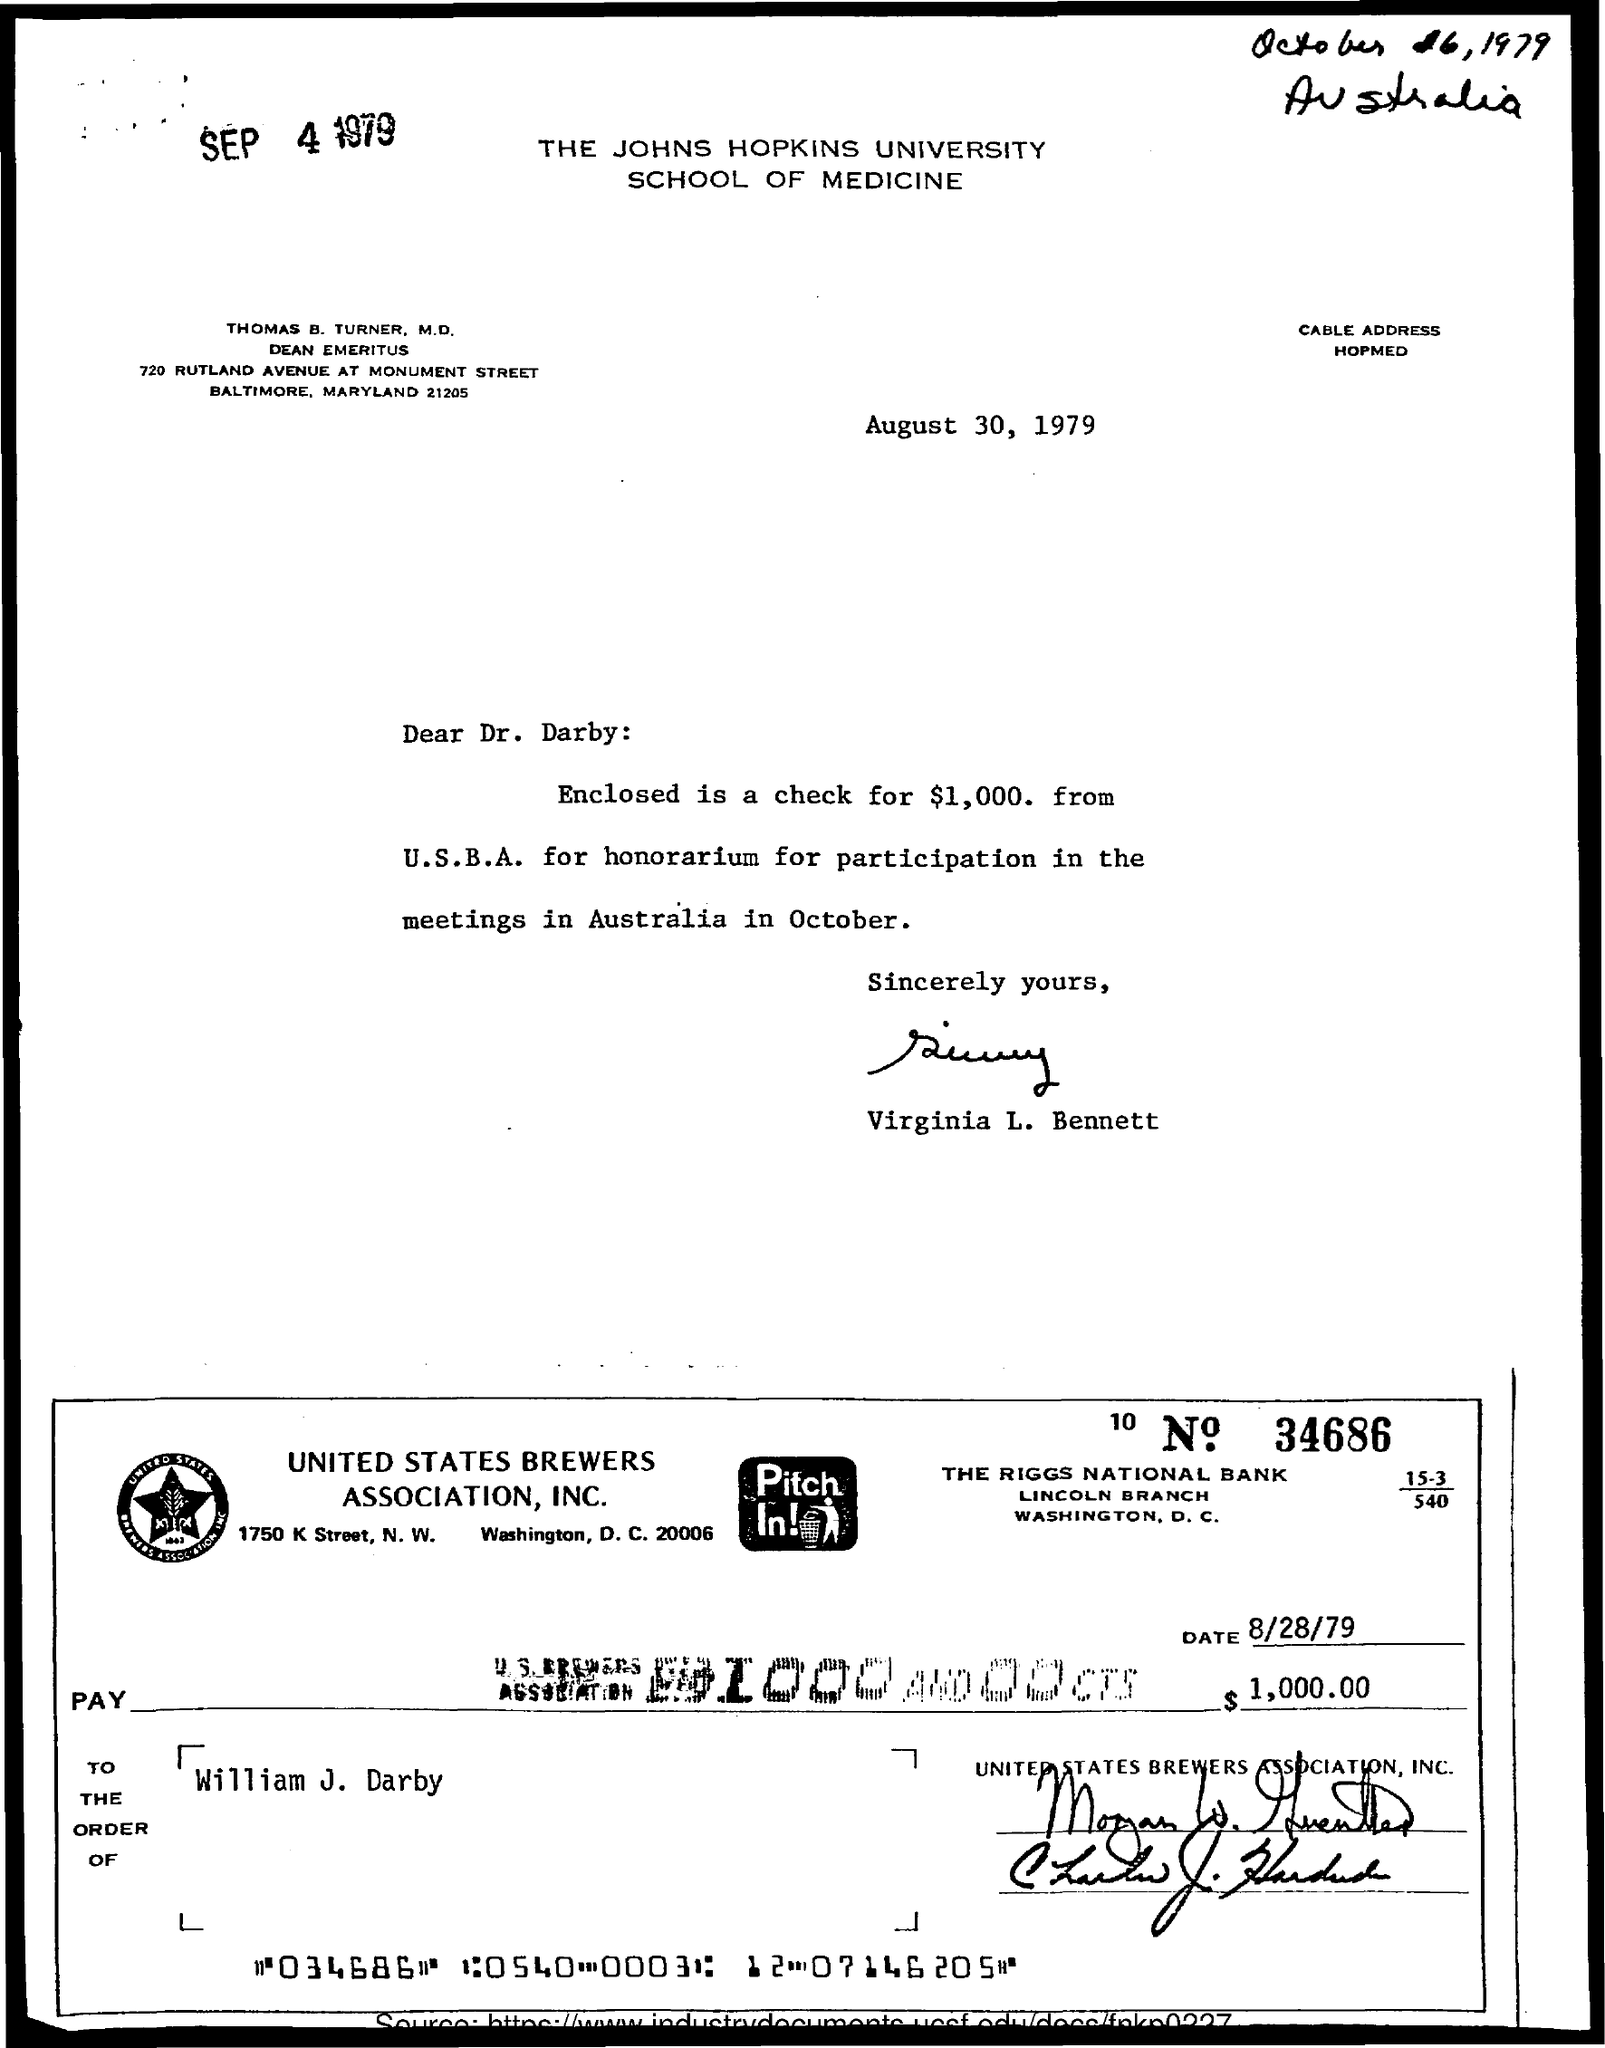Mention a couple of crucial points in this snapshot. The memorandum is from Virginia L. Bennett. The memorandum is addressed to Dr. Darby. The letterhead states that the Johns Hopkins University School of Medicine is written on it. 